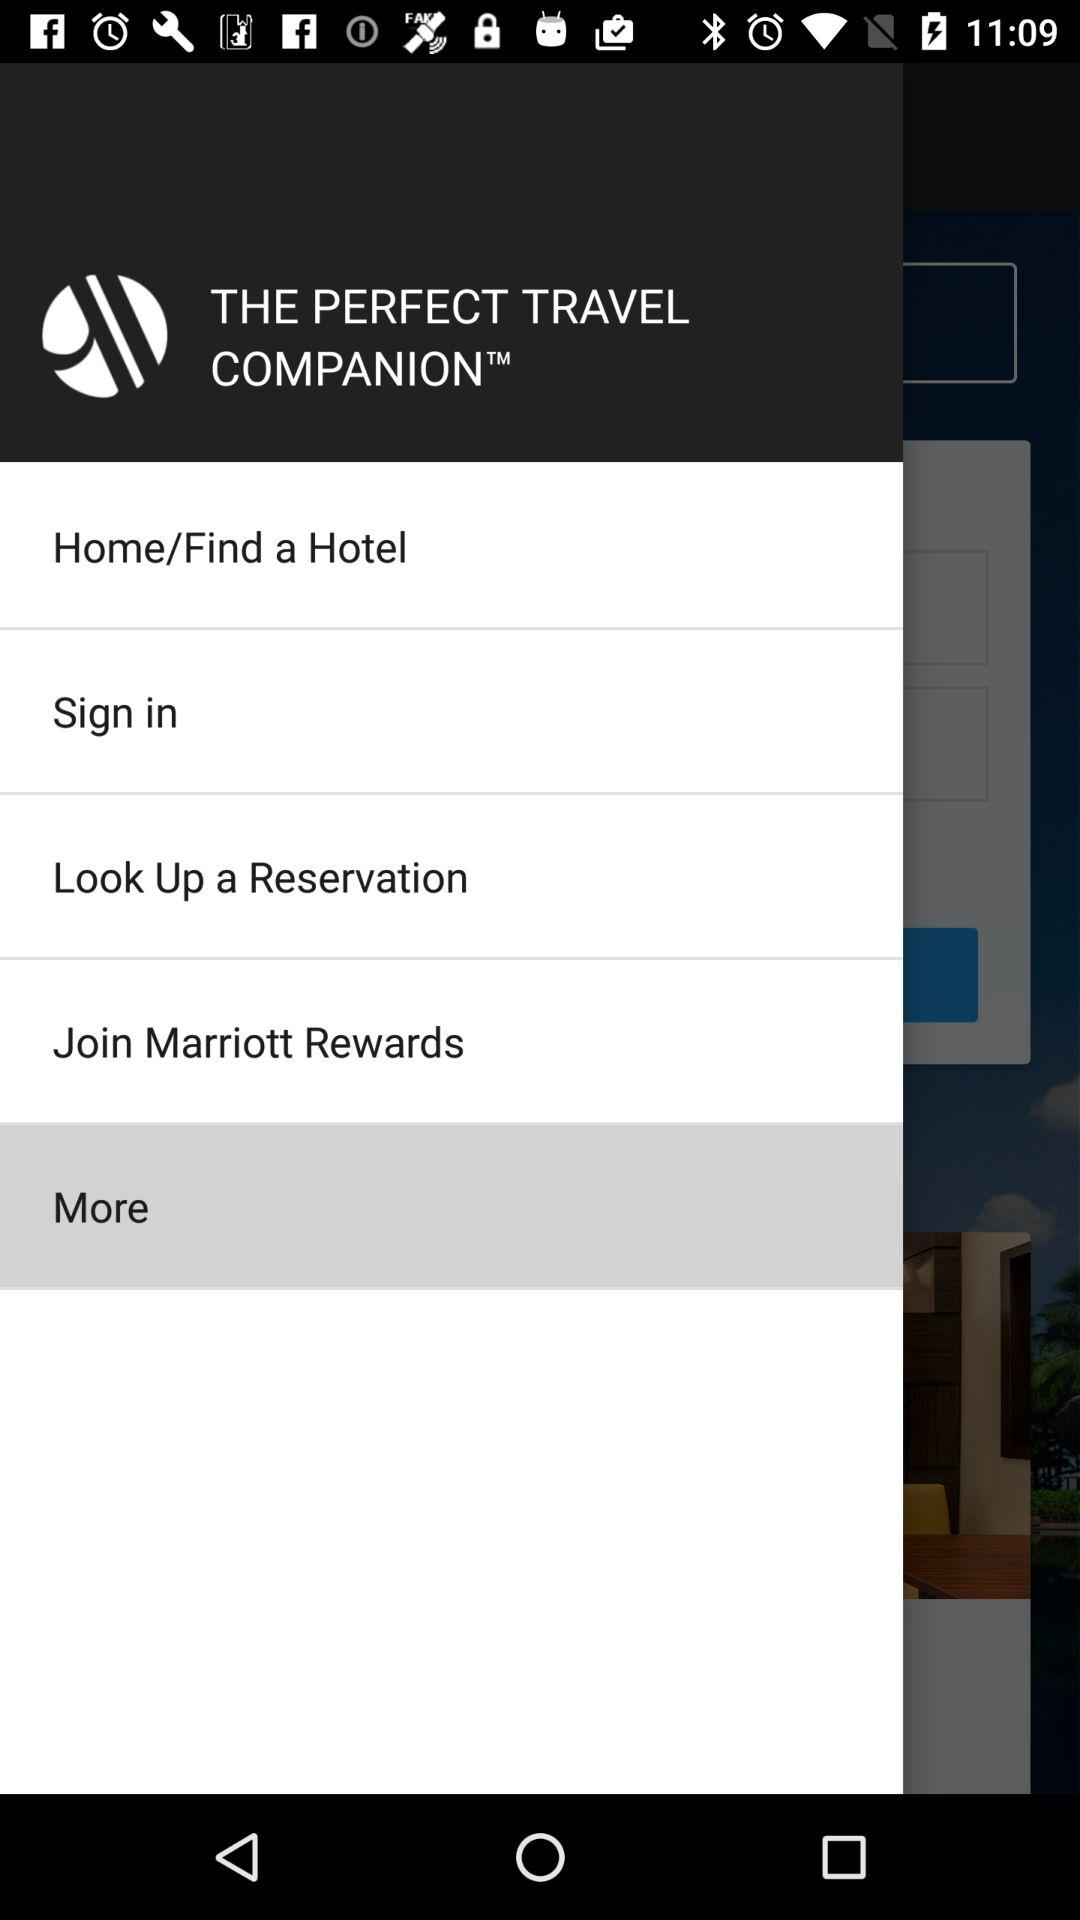What is the application name? The application name is "Marriott Mobile App". 